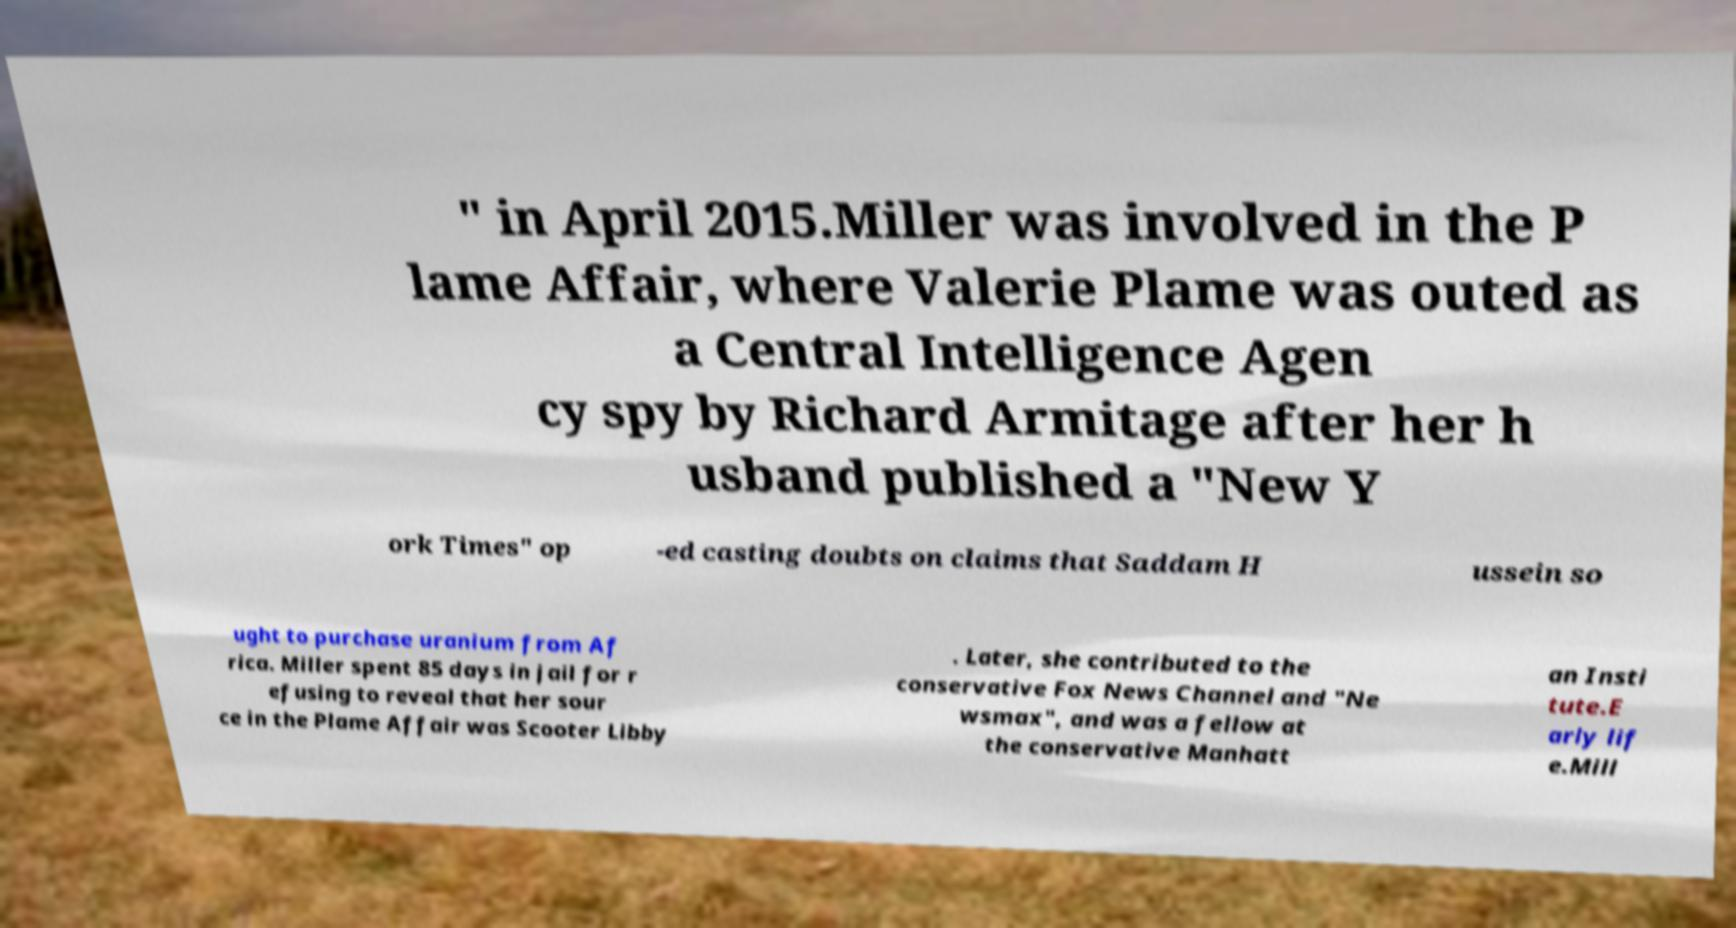I need the written content from this picture converted into text. Can you do that? " in April 2015.Miller was involved in the P lame Affair, where Valerie Plame was outed as a Central Intelligence Agen cy spy by Richard Armitage after her h usband published a "New Y ork Times" op -ed casting doubts on claims that Saddam H ussein so ught to purchase uranium from Af rica. Miller spent 85 days in jail for r efusing to reveal that her sour ce in the Plame Affair was Scooter Libby . Later, she contributed to the conservative Fox News Channel and "Ne wsmax", and was a fellow at the conservative Manhatt an Insti tute.E arly lif e.Mill 